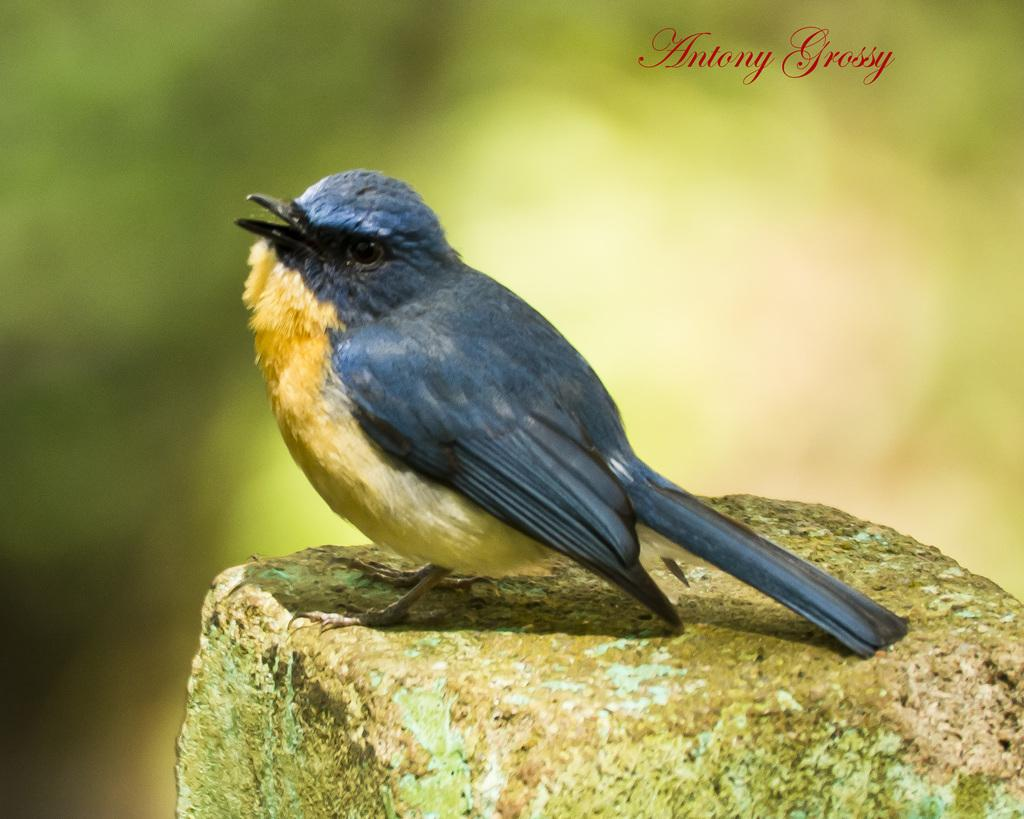What type of animal is in the image? There is a bird in the image. What colors can be seen on the bird? The bird has blue and yellow colors. What is the bird standing on? The bird is on a stone. What can be seen in the background of the image? The background of the image is blurred. Can you see any fairies playing harmonies on a skate in the image? No, there are no fairies or skates present in the image. The image features a bird on a stone with blue and yellow colors, water visible in the background, and a blurred background. 